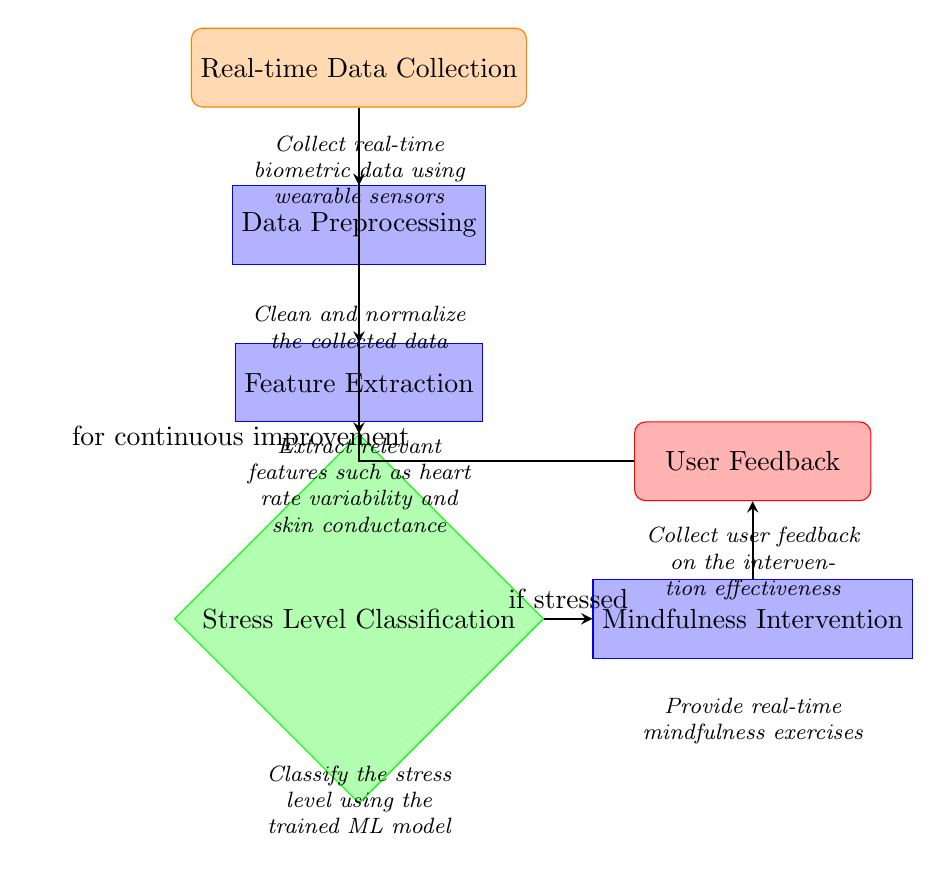What is the first step in the machine learning process? The first step in the diagram is "Real-time Data Collection," which is the initial node that gathers data using wearable sensors.
Answer: Real-time Data Collection How many main processes are there in the flowchart? The diagram contains four main processes: Data Preprocessing, Feature Extraction, Stress Level Classification, and Mindfulness Intervention.
Answer: Four What is the output of the process after "Mindfulness Intervention"? The output after "Mindfulness Intervention" is "User Feedback," which represents the assessment of the intervention effectiveness from the user.
Answer: User Feedback What happens if the stress level is classified as stressed? If the stress level is classified as stressed, the flow directs to "Mindfulness Intervention," indicating that an intervention is necessary for stress relief.
Answer: Mindfulness Intervention What type of data is collected in the first step? The first step involves the collection of "real-time biometric data," which suggests data related to the user's physical state such as heart rate and skin conductance.
Answer: Real-time biometric data How does user feedback contribute to the overall process? User feedback is collected to provide insights into the effectiveness of the mindfulness intervention, which is used for "continuous improvement" of the model and its suggestions.
Answer: Continuous improvement What is the relationship between "Feature Extraction" and "Stress Level Classification"? "Feature Extraction" is a prerequisite to "Stress Level Classification," as it processes the data to identify important features needed for the classification model.
Answer: Prerequisite What type of intervention is suggested in the machine learning process? The suggested intervention type mentioned in the diagram is "real-time mindfulness exercises," which aims to alleviate stress based on the detected levels.
Answer: Real-time mindfulness exercises 